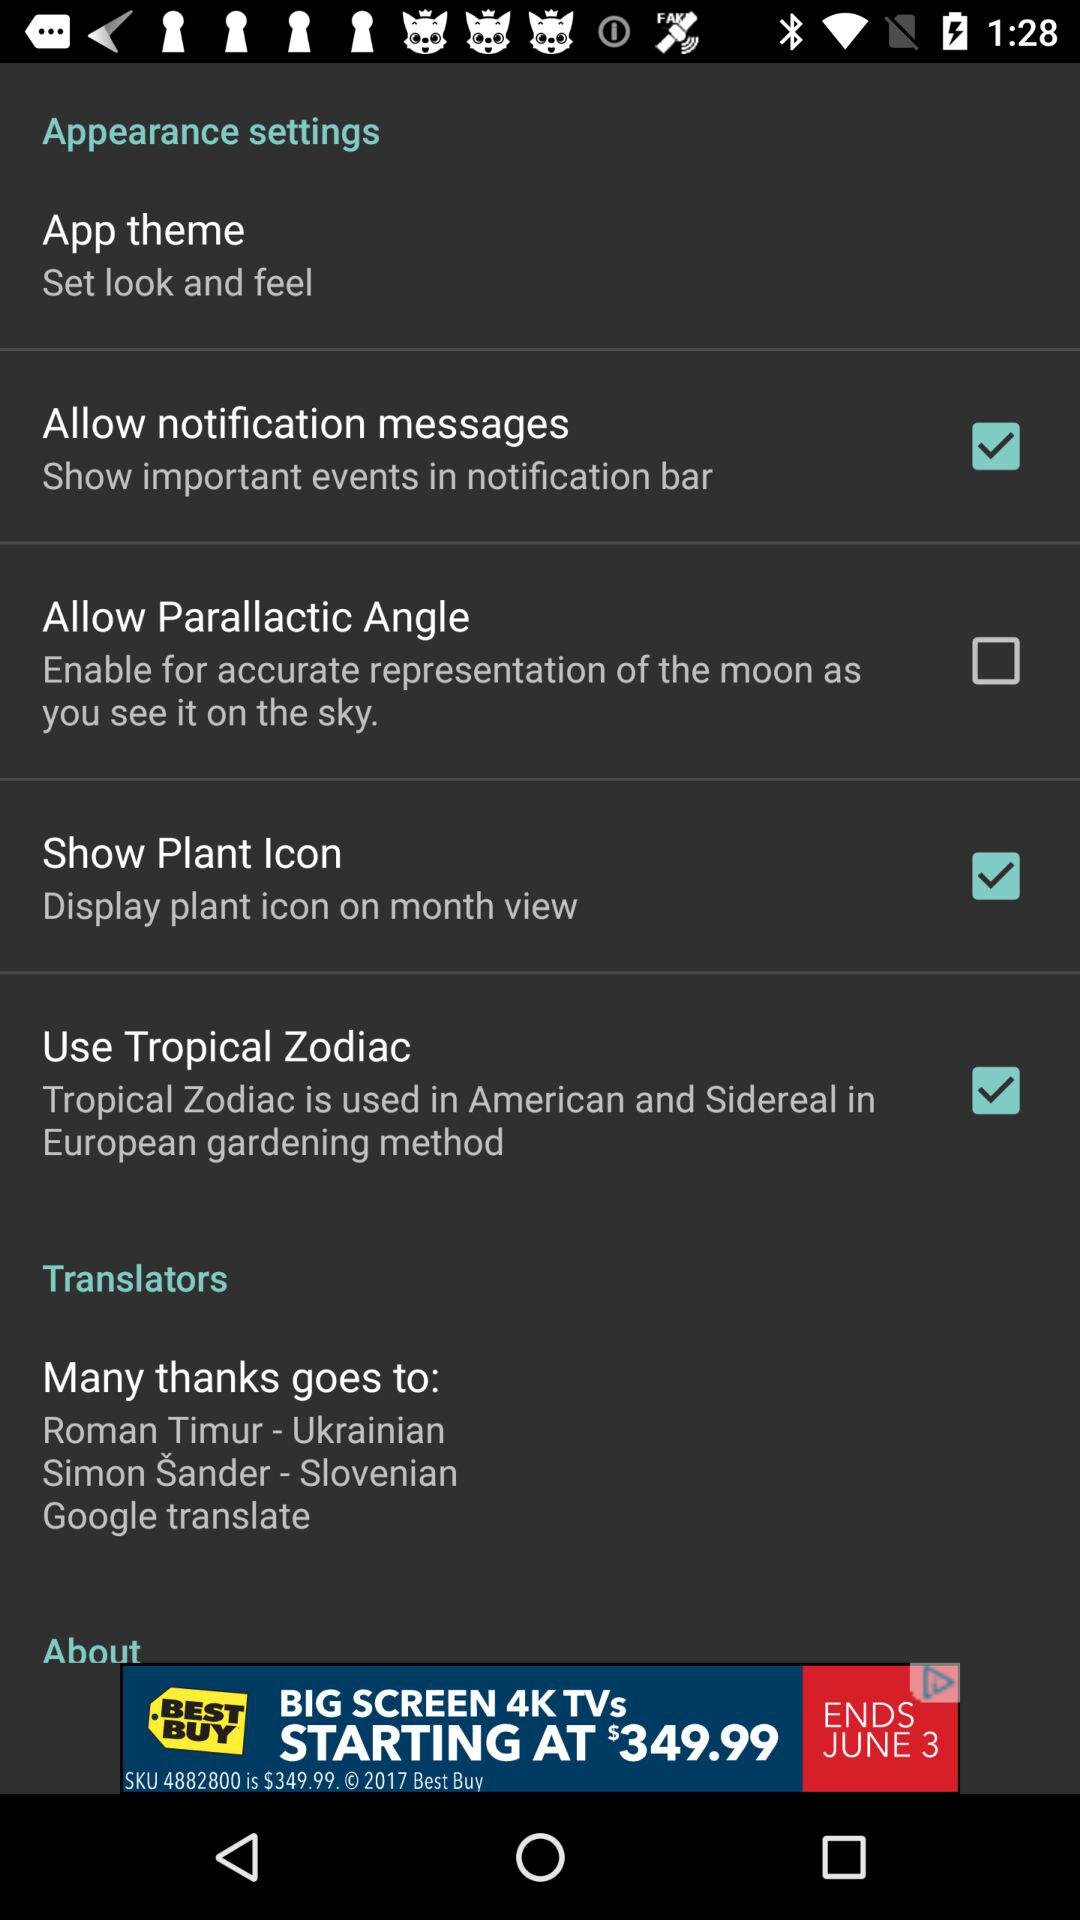What is the status of "Show Plant Icon"? The status is "on". 